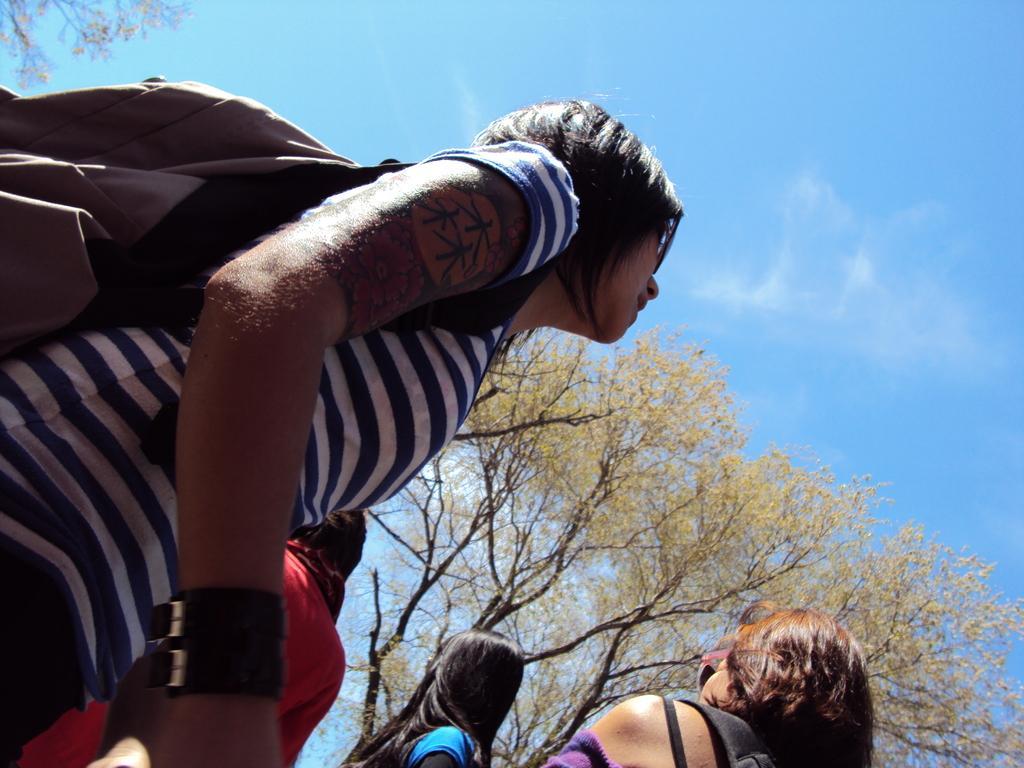Please provide a concise description of this image. In this image, there is an outside view. There is a person in the middle of the image wearing clothes and bag. There is a tree at the bottom of the image. In the background of the image, there is a sky. 